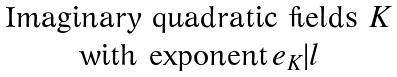<formula> <loc_0><loc_0><loc_500><loc_500>\begin{matrix} \text {Imaginary quadratic fields $K$} \\ \text {with exponent} \, e _ { K } | l \end{matrix}</formula> 